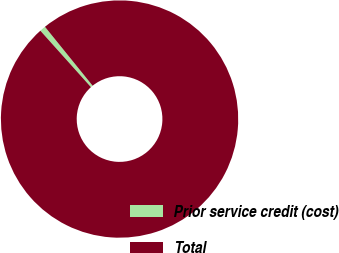<chart> <loc_0><loc_0><loc_500><loc_500><pie_chart><fcel>Prior service credit (cost)<fcel>Total<nl><fcel>0.81%<fcel>99.19%<nl></chart> 